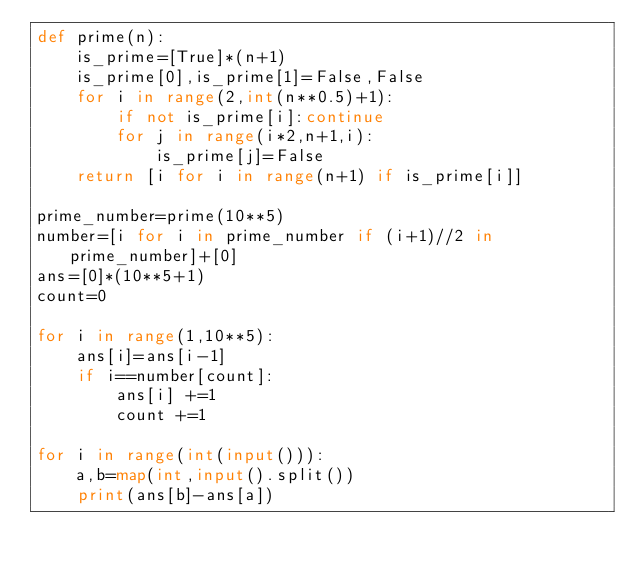<code> <loc_0><loc_0><loc_500><loc_500><_Python_>def prime(n):
    is_prime=[True]*(n+1)
    is_prime[0],is_prime[1]=False,False
    for i in range(2,int(n**0.5)+1):
        if not is_prime[i]:continue
        for j in range(i*2,n+1,i):
            is_prime[j]=False
    return [i for i in range(n+1) if is_prime[i]]

prime_number=prime(10**5)
number=[i for i in prime_number if (i+1)//2 in prime_number]+[0]
ans=[0]*(10**5+1)
count=0

for i in range(1,10**5):
    ans[i]=ans[i-1]
    if i==number[count]:
        ans[i] +=1
        count +=1

for i in range(int(input())):
    a,b=map(int,input().split())
    print(ans[b]-ans[a])</code> 